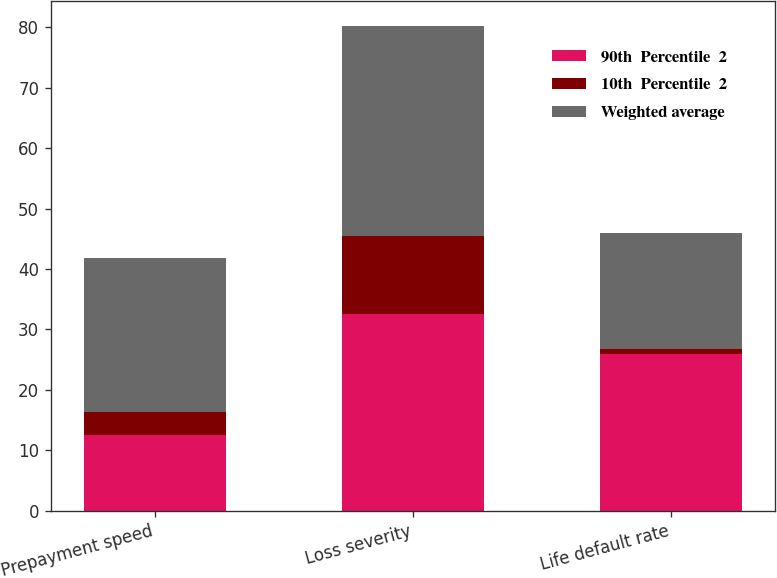Convert chart. <chart><loc_0><loc_0><loc_500><loc_500><stacked_bar_chart><ecel><fcel>Prepayment speed<fcel>Loss severity<fcel>Life default rate<nl><fcel>90th  Percentile  2<fcel>12.6<fcel>32.6<fcel>26<nl><fcel>10th  Percentile  2<fcel>3.8<fcel>12.9<fcel>0.8<nl><fcel>Weighted average<fcel>25.5<fcel>34.8<fcel>19.2<nl></chart> 